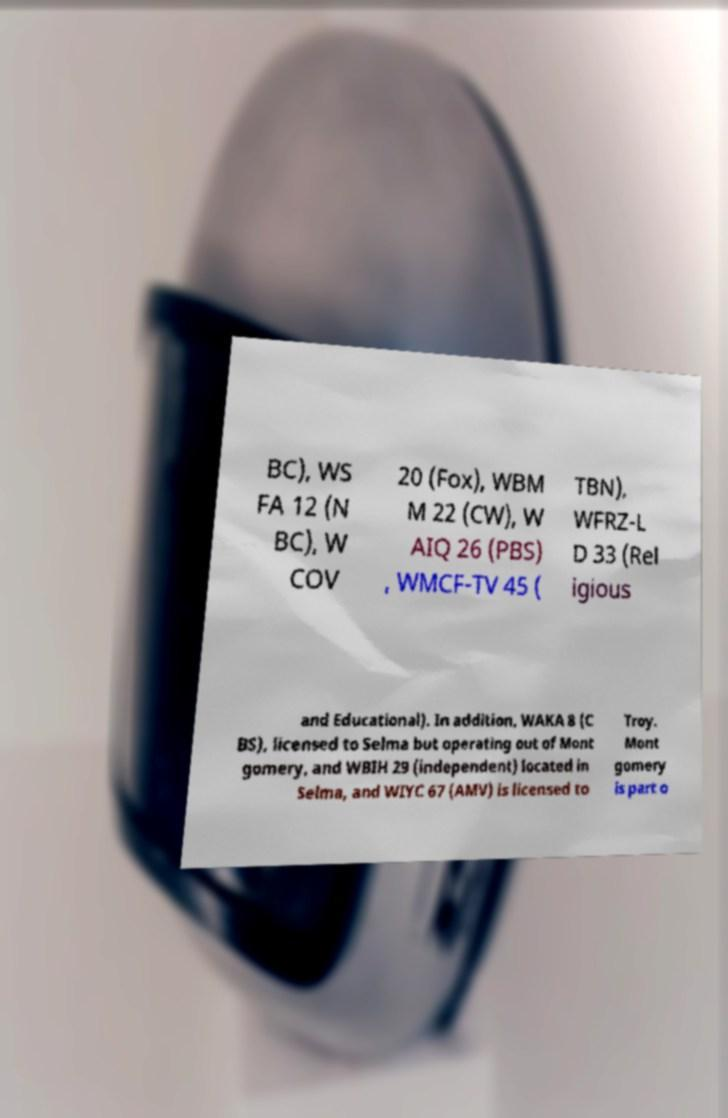Could you extract and type out the text from this image? BC), WS FA 12 (N BC), W COV 20 (Fox), WBM M 22 (CW), W AIQ 26 (PBS) , WMCF-TV 45 ( TBN), WFRZ-L D 33 (Rel igious and Educational). In addition, WAKA 8 (C BS), licensed to Selma but operating out of Mont gomery, and WBIH 29 (independent) located in Selma, and WIYC 67 (AMV) is licensed to Troy. Mont gomery is part o 